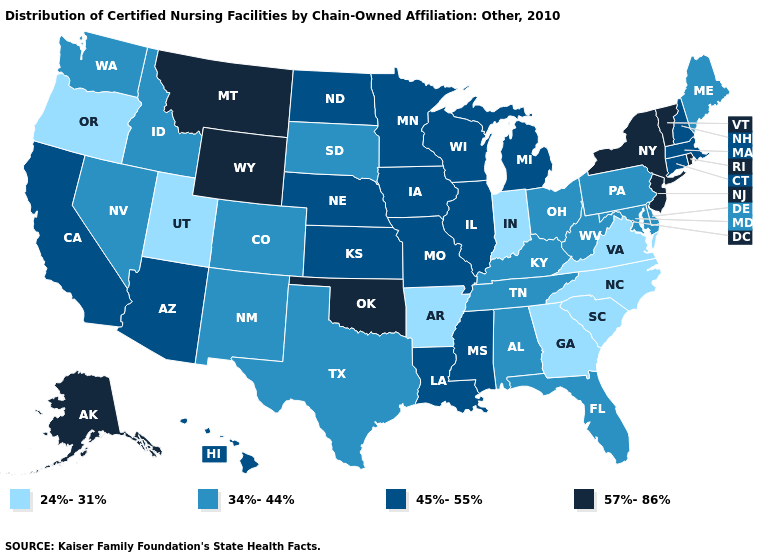Among the states that border Oklahoma , does Kansas have the highest value?
Give a very brief answer. Yes. What is the value of Ohio?
Give a very brief answer. 34%-44%. Among the states that border Texas , does Arkansas have the lowest value?
Short answer required. Yes. Among the states that border Illinois , does Iowa have the highest value?
Answer briefly. Yes. Among the states that border Kentucky , does Missouri have the highest value?
Short answer required. Yes. Which states have the lowest value in the South?
Be succinct. Arkansas, Georgia, North Carolina, South Carolina, Virginia. Does the map have missing data?
Be succinct. No. Does Rhode Island have the highest value in the Northeast?
Keep it brief. Yes. Which states have the lowest value in the MidWest?
Give a very brief answer. Indiana. Name the states that have a value in the range 45%-55%?
Keep it brief. Arizona, California, Connecticut, Hawaii, Illinois, Iowa, Kansas, Louisiana, Massachusetts, Michigan, Minnesota, Mississippi, Missouri, Nebraska, New Hampshire, North Dakota, Wisconsin. Name the states that have a value in the range 34%-44%?
Write a very short answer. Alabama, Colorado, Delaware, Florida, Idaho, Kentucky, Maine, Maryland, Nevada, New Mexico, Ohio, Pennsylvania, South Dakota, Tennessee, Texas, Washington, West Virginia. Does New York have the highest value in the Northeast?
Give a very brief answer. Yes. Does South Carolina have the lowest value in the South?
Be succinct. Yes. What is the value of Iowa?
Quick response, please. 45%-55%. Does Montana have the highest value in the USA?
Write a very short answer. Yes. 